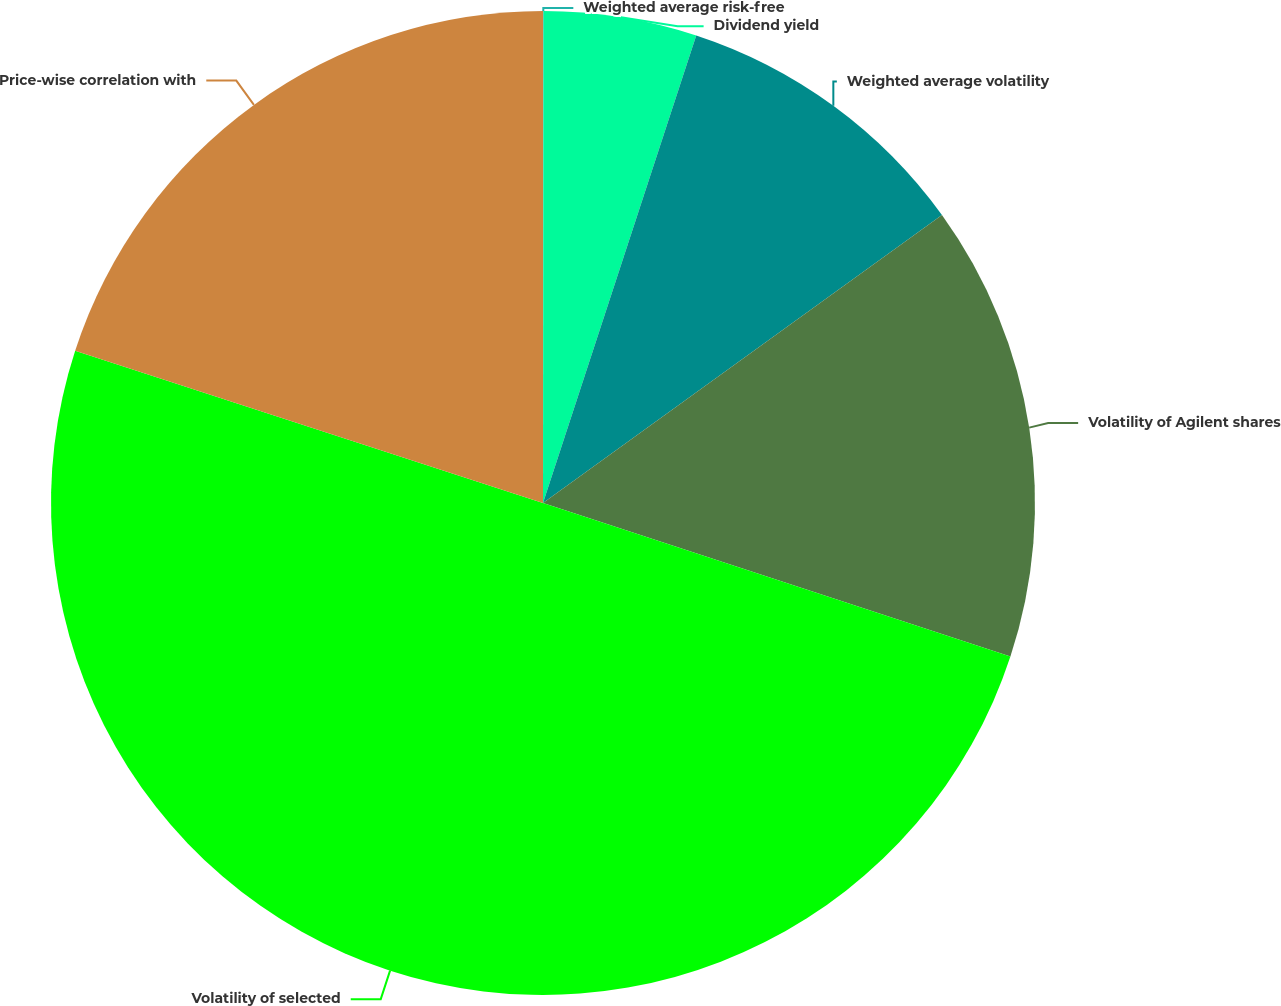<chart> <loc_0><loc_0><loc_500><loc_500><pie_chart><fcel>Weighted average risk-free<fcel>Dividend yield<fcel>Weighted average volatility<fcel>Volatility of Agilent shares<fcel>Volatility of selected<fcel>Price-wise correlation with<nl><fcel>0.02%<fcel>5.02%<fcel>10.01%<fcel>15.0%<fcel>49.95%<fcel>19.99%<nl></chart> 